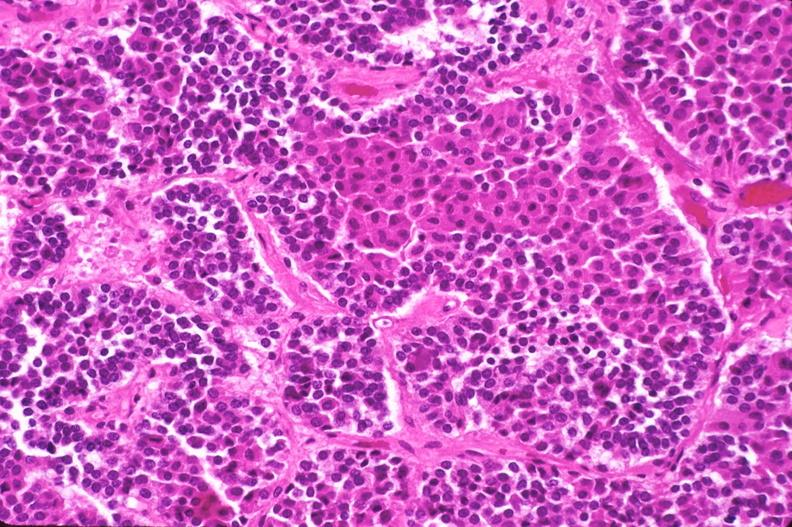what does this image show?
Answer the question using a single word or phrase. Pituitary 